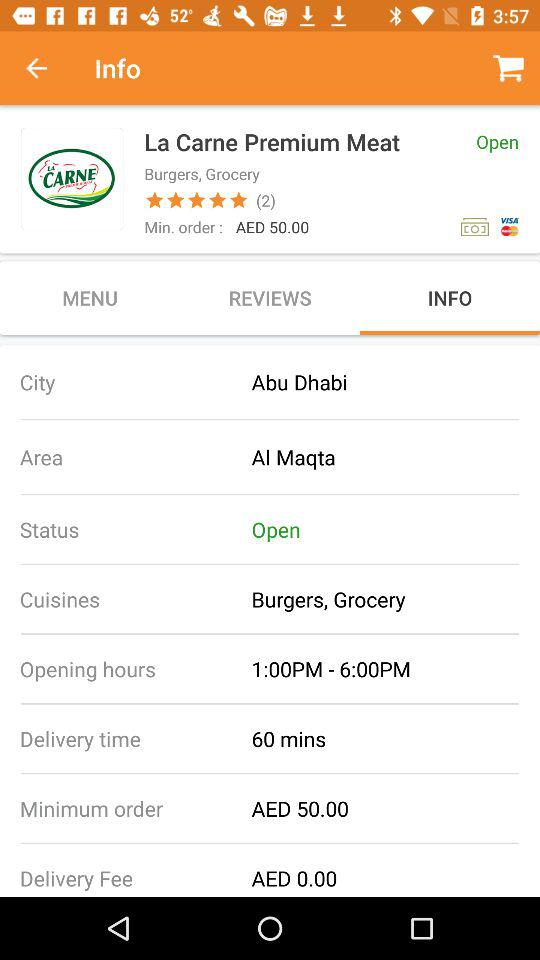How many ratings are shown? There are 2 ratings shown. 